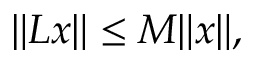Convert formula to latex. <formula><loc_0><loc_0><loc_500><loc_500>\| L x \| \leq M \| x \| ,</formula> 